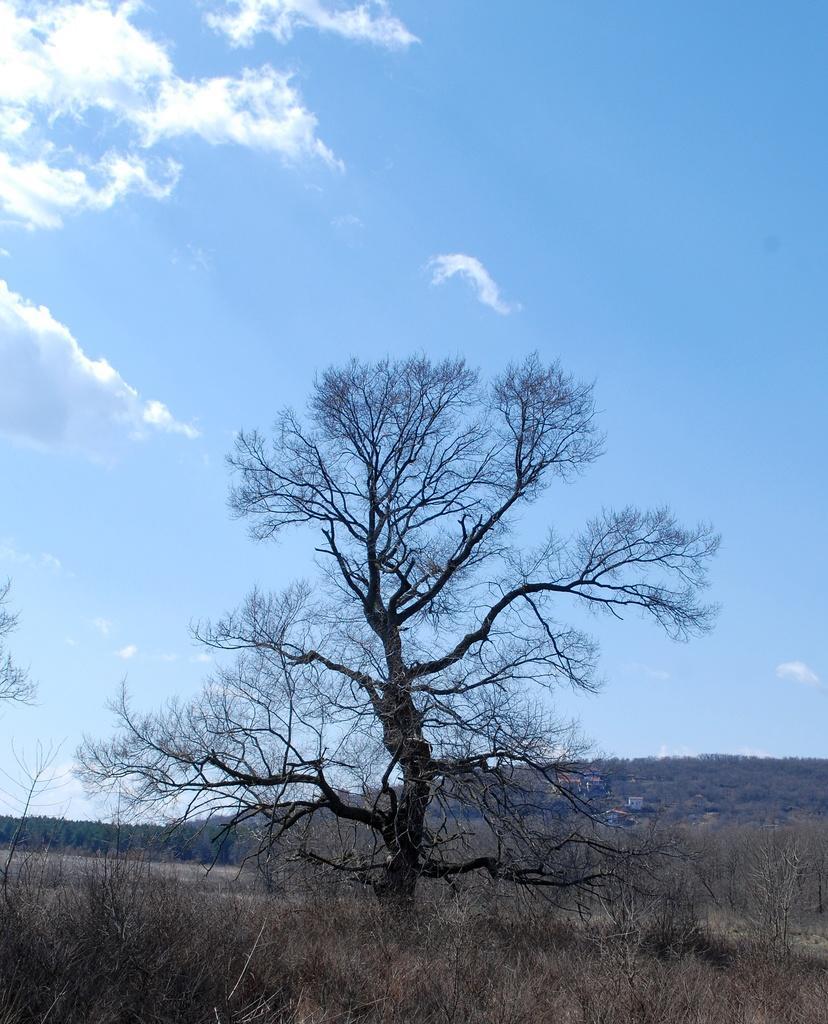Could you give a brief overview of what you see in this image? This picture is clicked outside the city. In the foreground we can see the dry grass and the dry tree. In the background there is a sky with some clouds and we can see some other objects. 